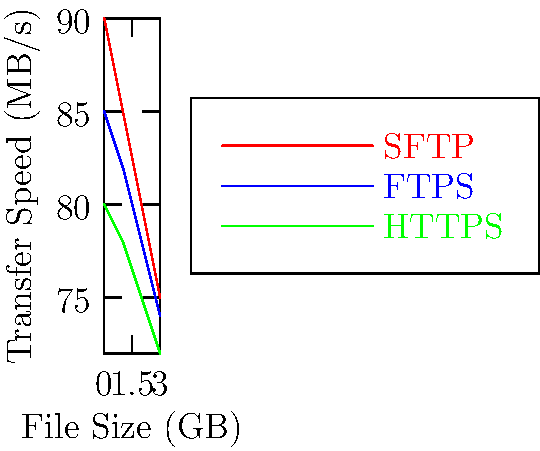In your latest film project, you're dealing with large file transfers during post-production. The graph shows the performance of three secure file transfer protocols: SFTP, FTPS, and HTTPS. Based on the data, which protocol consistently offers the highest transfer speed across different file sizes, potentially reducing time spent on technical aspects and allowing more focus on the artistic vision? To determine which protocol consistently offers the highest transfer speed, we need to analyze the graph step-by-step:

1. The graph shows transfer speeds (in MB/s) for three protocols: SFTP (red), FTPS (blue), and HTTPS (green) across different file sizes (0-3 GB).

2. Let's compare the speeds for each file size:

   At 0 GB:
   SFTP: 90 MB/s
   FTPS: 85 MB/s
   HTTPS: 80 MB/s

   At 1 GB:
   SFTP: 85 MB/s
   FTPS: 82 MB/s
   HTTPS: 78 MB/s

   At 2 GB:
   SFTP: 80 MB/s
   FTPS: 78 MB/s
   HTTPS: 75 MB/s

   At 3 GB:
   SFTP: 75 MB/s
   FTPS: 74 MB/s
   HTTPS: 72 MB/s

3. We can observe that SFTP (red line) consistently remains at the top of the graph, indicating the highest transfer speed across all file sizes.

4. While all protocols show a decrease in speed as file size increases, SFTP maintains its lead throughout the range.

Therefore, SFTP consistently offers the highest transfer speed across different file sizes, potentially reducing time spent on file transfers during post-production.
Answer: SFTP 